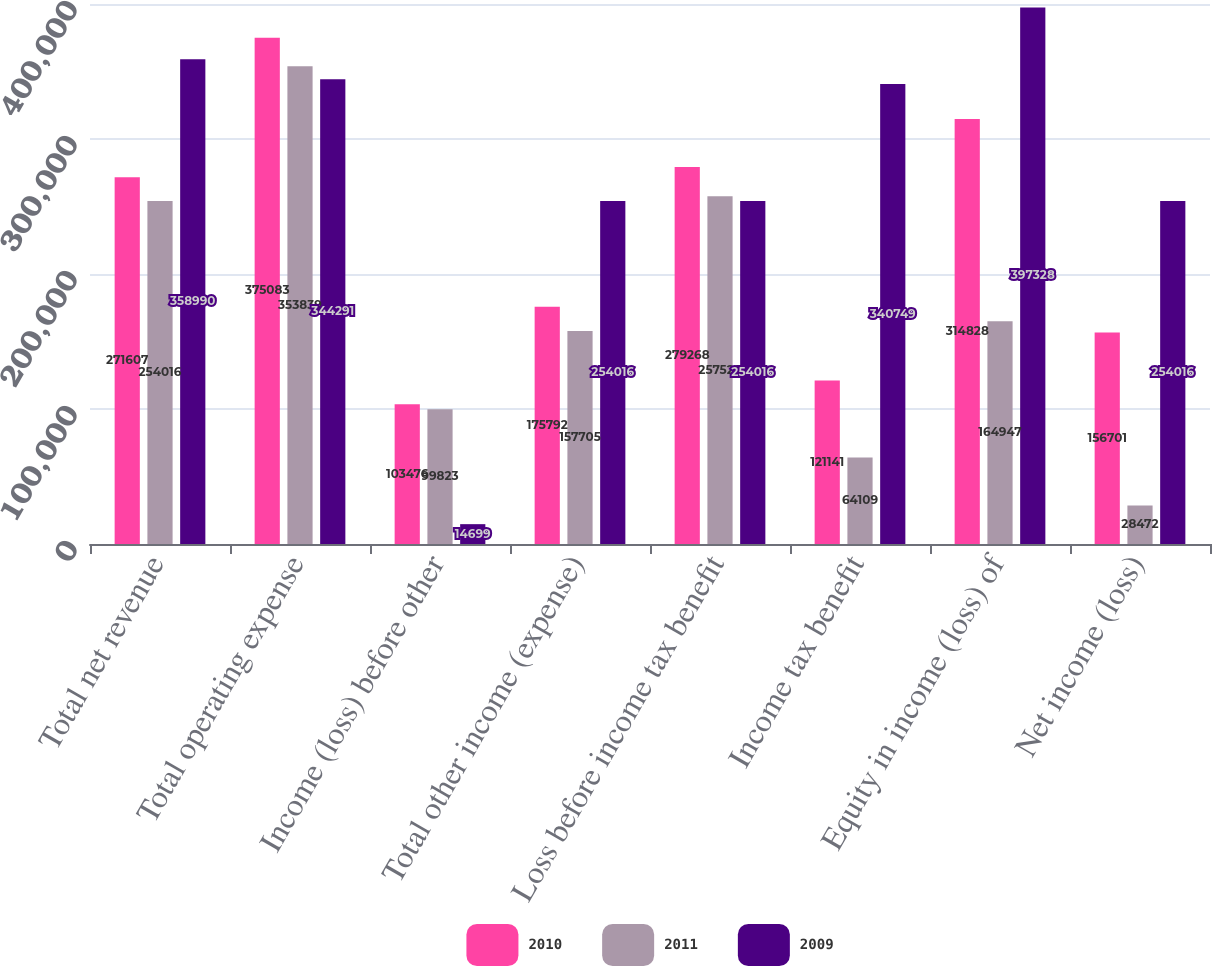Convert chart. <chart><loc_0><loc_0><loc_500><loc_500><stacked_bar_chart><ecel><fcel>Total net revenue<fcel>Total operating expense<fcel>Income (loss) before other<fcel>Total other income (expense)<fcel>Loss before income tax benefit<fcel>Income tax benefit<fcel>Equity in income (loss) of<fcel>Net income (loss)<nl><fcel>2010<fcel>271607<fcel>375083<fcel>103476<fcel>175792<fcel>279268<fcel>121141<fcel>314828<fcel>156701<nl><fcel>2011<fcel>254016<fcel>353839<fcel>99823<fcel>157705<fcel>257528<fcel>64109<fcel>164947<fcel>28472<nl><fcel>2009<fcel>358990<fcel>344291<fcel>14699<fcel>254016<fcel>254016<fcel>340749<fcel>397328<fcel>254016<nl></chart> 